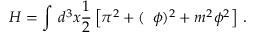<formula> <loc_0><loc_0><loc_500><loc_500>H = \int \, d ^ { 3 } x \frac { 1 } { 2 } \left [ \pi ^ { 2 } + ( \, \phi ) ^ { 2 } + m ^ { 2 } \phi ^ { 2 } \right ] \, .</formula> 